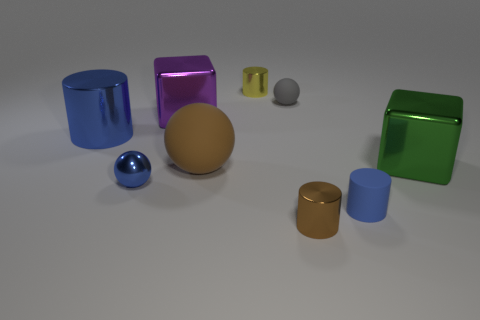Do the small object on the left side of the big brown rubber object and the rubber cylinder have the same color?
Your answer should be compact. Yes. There is a yellow shiny thing that is the same shape as the blue rubber object; what is its size?
Provide a short and direct response. Small. There is a tiny shiny cylinder that is on the right side of the tiny ball that is behind the large metallic cube that is right of the big purple cube; what is its color?
Keep it short and to the point. Brown. Is the material of the gray thing the same as the brown cylinder?
Your response must be concise. No. There is a large block on the left side of the blue object that is to the right of the big purple object; is there a green metal block that is to the right of it?
Your answer should be compact. Yes. Does the big cylinder have the same color as the metal ball?
Keep it short and to the point. Yes. Are there fewer blue balls than large yellow shiny things?
Ensure brevity in your answer.  No. Is the blue cylinder behind the blue shiny ball made of the same material as the blue object in front of the metallic sphere?
Provide a succinct answer. No. Is the number of blue metallic things that are on the right side of the tiny blue rubber cylinder less than the number of large cyan blocks?
Offer a very short reply. No. There is a tiny cylinder to the right of the brown metallic cylinder; how many spheres are to the right of it?
Ensure brevity in your answer.  0. 